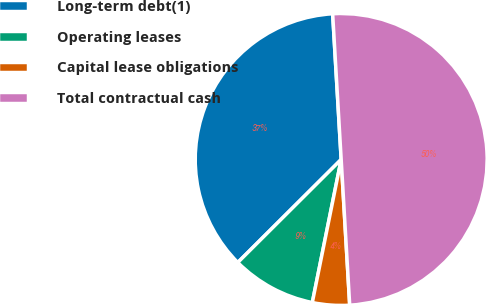Convert chart. <chart><loc_0><loc_0><loc_500><loc_500><pie_chart><fcel>Long-term debt(1)<fcel>Operating leases<fcel>Capital lease obligations<fcel>Total contractual cash<nl><fcel>36.54%<fcel>9.36%<fcel>4.1%<fcel>50.0%<nl></chart> 